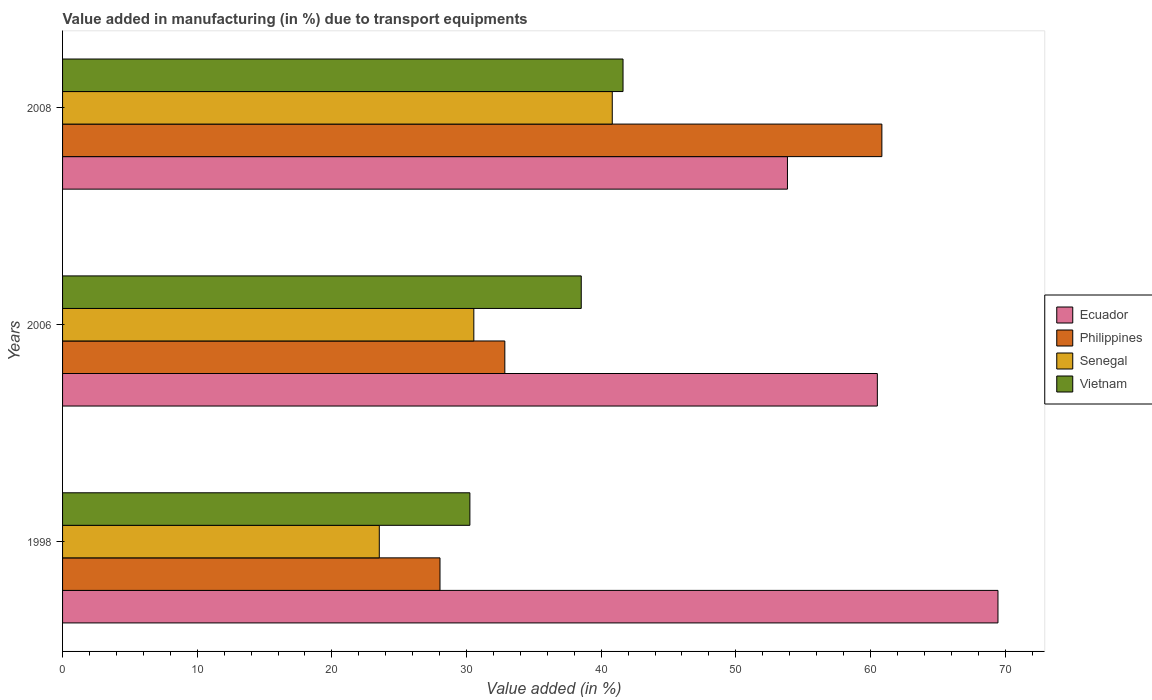How many groups of bars are there?
Provide a short and direct response. 3. How many bars are there on the 2nd tick from the top?
Make the answer very short. 4. What is the percentage of value added in manufacturing due to transport equipments in Philippines in 2006?
Your answer should be compact. 32.84. Across all years, what is the maximum percentage of value added in manufacturing due to transport equipments in Ecuador?
Make the answer very short. 69.47. Across all years, what is the minimum percentage of value added in manufacturing due to transport equipments in Senegal?
Keep it short and to the point. 23.52. In which year was the percentage of value added in manufacturing due to transport equipments in Ecuador maximum?
Your answer should be very brief. 1998. What is the total percentage of value added in manufacturing due to transport equipments in Ecuador in the graph?
Keep it short and to the point. 183.81. What is the difference between the percentage of value added in manufacturing due to transport equipments in Ecuador in 2006 and that in 2008?
Ensure brevity in your answer.  6.68. What is the difference between the percentage of value added in manufacturing due to transport equipments in Vietnam in 2008 and the percentage of value added in manufacturing due to transport equipments in Ecuador in 1998?
Provide a short and direct response. -27.85. What is the average percentage of value added in manufacturing due to transport equipments in Philippines per year?
Ensure brevity in your answer.  40.57. In the year 1998, what is the difference between the percentage of value added in manufacturing due to transport equipments in Senegal and percentage of value added in manufacturing due to transport equipments in Ecuador?
Make the answer very short. -45.95. What is the ratio of the percentage of value added in manufacturing due to transport equipments in Senegal in 1998 to that in 2006?
Your answer should be very brief. 0.77. Is the difference between the percentage of value added in manufacturing due to transport equipments in Senegal in 1998 and 2006 greater than the difference between the percentage of value added in manufacturing due to transport equipments in Ecuador in 1998 and 2006?
Give a very brief answer. No. What is the difference between the highest and the second highest percentage of value added in manufacturing due to transport equipments in Philippines?
Offer a very short reply. 28. What is the difference between the highest and the lowest percentage of value added in manufacturing due to transport equipments in Ecuador?
Give a very brief answer. 15.63. Is it the case that in every year, the sum of the percentage of value added in manufacturing due to transport equipments in Ecuador and percentage of value added in manufacturing due to transport equipments in Vietnam is greater than the sum of percentage of value added in manufacturing due to transport equipments in Senegal and percentage of value added in manufacturing due to transport equipments in Philippines?
Your answer should be very brief. No. What does the 4th bar from the top in 2006 represents?
Ensure brevity in your answer.  Ecuador. What does the 2nd bar from the bottom in 2008 represents?
Your answer should be very brief. Philippines. Is it the case that in every year, the sum of the percentage of value added in manufacturing due to transport equipments in Vietnam and percentage of value added in manufacturing due to transport equipments in Ecuador is greater than the percentage of value added in manufacturing due to transport equipments in Philippines?
Keep it short and to the point. Yes. How many legend labels are there?
Keep it short and to the point. 4. What is the title of the graph?
Your answer should be compact. Value added in manufacturing (in %) due to transport equipments. What is the label or title of the X-axis?
Your response must be concise. Value added (in %). What is the Value added (in %) in Ecuador in 1998?
Ensure brevity in your answer.  69.47. What is the Value added (in %) of Philippines in 1998?
Your answer should be very brief. 28.03. What is the Value added (in %) in Senegal in 1998?
Offer a very short reply. 23.52. What is the Value added (in %) in Vietnam in 1998?
Offer a terse response. 30.25. What is the Value added (in %) in Ecuador in 2006?
Make the answer very short. 60.51. What is the Value added (in %) of Philippines in 2006?
Provide a short and direct response. 32.84. What is the Value added (in %) of Senegal in 2006?
Provide a succinct answer. 30.54. What is the Value added (in %) in Vietnam in 2006?
Offer a terse response. 38.52. What is the Value added (in %) in Ecuador in 2008?
Your response must be concise. 53.83. What is the Value added (in %) of Philippines in 2008?
Provide a short and direct response. 60.85. What is the Value added (in %) in Senegal in 2008?
Your answer should be very brief. 40.82. What is the Value added (in %) of Vietnam in 2008?
Ensure brevity in your answer.  41.62. Across all years, what is the maximum Value added (in %) of Ecuador?
Keep it short and to the point. 69.47. Across all years, what is the maximum Value added (in %) in Philippines?
Your response must be concise. 60.85. Across all years, what is the maximum Value added (in %) in Senegal?
Your response must be concise. 40.82. Across all years, what is the maximum Value added (in %) in Vietnam?
Ensure brevity in your answer.  41.62. Across all years, what is the minimum Value added (in %) in Ecuador?
Your answer should be compact. 53.83. Across all years, what is the minimum Value added (in %) of Philippines?
Give a very brief answer. 28.03. Across all years, what is the minimum Value added (in %) of Senegal?
Your response must be concise. 23.52. Across all years, what is the minimum Value added (in %) in Vietnam?
Offer a terse response. 30.25. What is the total Value added (in %) of Ecuador in the graph?
Provide a short and direct response. 183.81. What is the total Value added (in %) of Philippines in the graph?
Offer a terse response. 121.72. What is the total Value added (in %) of Senegal in the graph?
Give a very brief answer. 94.89. What is the total Value added (in %) in Vietnam in the graph?
Provide a succinct answer. 110.39. What is the difference between the Value added (in %) of Ecuador in 1998 and that in 2006?
Provide a succinct answer. 8.96. What is the difference between the Value added (in %) of Philippines in 1998 and that in 2006?
Your response must be concise. -4.81. What is the difference between the Value added (in %) in Senegal in 1998 and that in 2006?
Your answer should be very brief. -7.02. What is the difference between the Value added (in %) of Vietnam in 1998 and that in 2006?
Your answer should be very brief. -8.27. What is the difference between the Value added (in %) of Ecuador in 1998 and that in 2008?
Provide a succinct answer. 15.63. What is the difference between the Value added (in %) of Philippines in 1998 and that in 2008?
Your answer should be very brief. -32.82. What is the difference between the Value added (in %) of Senegal in 1998 and that in 2008?
Keep it short and to the point. -17.3. What is the difference between the Value added (in %) in Vietnam in 1998 and that in 2008?
Offer a very short reply. -11.37. What is the difference between the Value added (in %) of Ecuador in 2006 and that in 2008?
Your answer should be compact. 6.68. What is the difference between the Value added (in %) in Philippines in 2006 and that in 2008?
Offer a very short reply. -28. What is the difference between the Value added (in %) in Senegal in 2006 and that in 2008?
Your answer should be compact. -10.28. What is the difference between the Value added (in %) in Vietnam in 2006 and that in 2008?
Provide a short and direct response. -3.1. What is the difference between the Value added (in %) of Ecuador in 1998 and the Value added (in %) of Philippines in 2006?
Your answer should be very brief. 36.62. What is the difference between the Value added (in %) in Ecuador in 1998 and the Value added (in %) in Senegal in 2006?
Your answer should be very brief. 38.93. What is the difference between the Value added (in %) of Ecuador in 1998 and the Value added (in %) of Vietnam in 2006?
Your answer should be very brief. 30.95. What is the difference between the Value added (in %) in Philippines in 1998 and the Value added (in %) in Senegal in 2006?
Ensure brevity in your answer.  -2.51. What is the difference between the Value added (in %) in Philippines in 1998 and the Value added (in %) in Vietnam in 2006?
Your response must be concise. -10.49. What is the difference between the Value added (in %) of Senegal in 1998 and the Value added (in %) of Vietnam in 2006?
Your answer should be very brief. -15. What is the difference between the Value added (in %) of Ecuador in 1998 and the Value added (in %) of Philippines in 2008?
Your response must be concise. 8.62. What is the difference between the Value added (in %) of Ecuador in 1998 and the Value added (in %) of Senegal in 2008?
Provide a short and direct response. 28.65. What is the difference between the Value added (in %) in Ecuador in 1998 and the Value added (in %) in Vietnam in 2008?
Provide a short and direct response. 27.85. What is the difference between the Value added (in %) of Philippines in 1998 and the Value added (in %) of Senegal in 2008?
Your response must be concise. -12.79. What is the difference between the Value added (in %) in Philippines in 1998 and the Value added (in %) in Vietnam in 2008?
Provide a succinct answer. -13.59. What is the difference between the Value added (in %) of Senegal in 1998 and the Value added (in %) of Vietnam in 2008?
Make the answer very short. -18.1. What is the difference between the Value added (in %) in Ecuador in 2006 and the Value added (in %) in Philippines in 2008?
Your answer should be compact. -0.34. What is the difference between the Value added (in %) in Ecuador in 2006 and the Value added (in %) in Senegal in 2008?
Give a very brief answer. 19.69. What is the difference between the Value added (in %) in Ecuador in 2006 and the Value added (in %) in Vietnam in 2008?
Ensure brevity in your answer.  18.89. What is the difference between the Value added (in %) in Philippines in 2006 and the Value added (in %) in Senegal in 2008?
Your answer should be compact. -7.98. What is the difference between the Value added (in %) in Philippines in 2006 and the Value added (in %) in Vietnam in 2008?
Your response must be concise. -8.78. What is the difference between the Value added (in %) in Senegal in 2006 and the Value added (in %) in Vietnam in 2008?
Your answer should be compact. -11.08. What is the average Value added (in %) in Ecuador per year?
Ensure brevity in your answer.  61.27. What is the average Value added (in %) in Philippines per year?
Give a very brief answer. 40.57. What is the average Value added (in %) in Senegal per year?
Provide a succinct answer. 31.63. What is the average Value added (in %) in Vietnam per year?
Ensure brevity in your answer.  36.8. In the year 1998, what is the difference between the Value added (in %) of Ecuador and Value added (in %) of Philippines?
Your answer should be compact. 41.44. In the year 1998, what is the difference between the Value added (in %) in Ecuador and Value added (in %) in Senegal?
Give a very brief answer. 45.95. In the year 1998, what is the difference between the Value added (in %) in Ecuador and Value added (in %) in Vietnam?
Keep it short and to the point. 39.22. In the year 1998, what is the difference between the Value added (in %) in Philippines and Value added (in %) in Senegal?
Make the answer very short. 4.51. In the year 1998, what is the difference between the Value added (in %) of Philippines and Value added (in %) of Vietnam?
Your answer should be compact. -2.22. In the year 1998, what is the difference between the Value added (in %) of Senegal and Value added (in %) of Vietnam?
Keep it short and to the point. -6.73. In the year 2006, what is the difference between the Value added (in %) of Ecuador and Value added (in %) of Philippines?
Make the answer very short. 27.67. In the year 2006, what is the difference between the Value added (in %) in Ecuador and Value added (in %) in Senegal?
Offer a very short reply. 29.97. In the year 2006, what is the difference between the Value added (in %) of Ecuador and Value added (in %) of Vietnam?
Ensure brevity in your answer.  21.99. In the year 2006, what is the difference between the Value added (in %) in Philippines and Value added (in %) in Senegal?
Keep it short and to the point. 2.3. In the year 2006, what is the difference between the Value added (in %) in Philippines and Value added (in %) in Vietnam?
Offer a very short reply. -5.68. In the year 2006, what is the difference between the Value added (in %) of Senegal and Value added (in %) of Vietnam?
Provide a short and direct response. -7.98. In the year 2008, what is the difference between the Value added (in %) in Ecuador and Value added (in %) in Philippines?
Provide a succinct answer. -7.01. In the year 2008, what is the difference between the Value added (in %) of Ecuador and Value added (in %) of Senegal?
Your answer should be very brief. 13.01. In the year 2008, what is the difference between the Value added (in %) of Ecuador and Value added (in %) of Vietnam?
Your answer should be compact. 12.21. In the year 2008, what is the difference between the Value added (in %) in Philippines and Value added (in %) in Senegal?
Keep it short and to the point. 20.02. In the year 2008, what is the difference between the Value added (in %) of Philippines and Value added (in %) of Vietnam?
Make the answer very short. 19.22. What is the ratio of the Value added (in %) in Ecuador in 1998 to that in 2006?
Offer a terse response. 1.15. What is the ratio of the Value added (in %) of Philippines in 1998 to that in 2006?
Offer a very short reply. 0.85. What is the ratio of the Value added (in %) of Senegal in 1998 to that in 2006?
Your response must be concise. 0.77. What is the ratio of the Value added (in %) of Vietnam in 1998 to that in 2006?
Provide a succinct answer. 0.79. What is the ratio of the Value added (in %) in Ecuador in 1998 to that in 2008?
Your answer should be compact. 1.29. What is the ratio of the Value added (in %) of Philippines in 1998 to that in 2008?
Your response must be concise. 0.46. What is the ratio of the Value added (in %) in Senegal in 1998 to that in 2008?
Your answer should be compact. 0.58. What is the ratio of the Value added (in %) of Vietnam in 1998 to that in 2008?
Make the answer very short. 0.73. What is the ratio of the Value added (in %) in Ecuador in 2006 to that in 2008?
Ensure brevity in your answer.  1.12. What is the ratio of the Value added (in %) in Philippines in 2006 to that in 2008?
Keep it short and to the point. 0.54. What is the ratio of the Value added (in %) of Senegal in 2006 to that in 2008?
Make the answer very short. 0.75. What is the ratio of the Value added (in %) in Vietnam in 2006 to that in 2008?
Your response must be concise. 0.93. What is the difference between the highest and the second highest Value added (in %) of Ecuador?
Ensure brevity in your answer.  8.96. What is the difference between the highest and the second highest Value added (in %) in Philippines?
Give a very brief answer. 28. What is the difference between the highest and the second highest Value added (in %) in Senegal?
Provide a short and direct response. 10.28. What is the difference between the highest and the second highest Value added (in %) in Vietnam?
Your response must be concise. 3.1. What is the difference between the highest and the lowest Value added (in %) in Ecuador?
Provide a short and direct response. 15.63. What is the difference between the highest and the lowest Value added (in %) of Philippines?
Ensure brevity in your answer.  32.82. What is the difference between the highest and the lowest Value added (in %) of Senegal?
Make the answer very short. 17.3. What is the difference between the highest and the lowest Value added (in %) of Vietnam?
Your response must be concise. 11.37. 